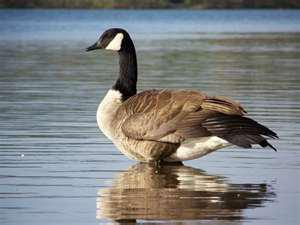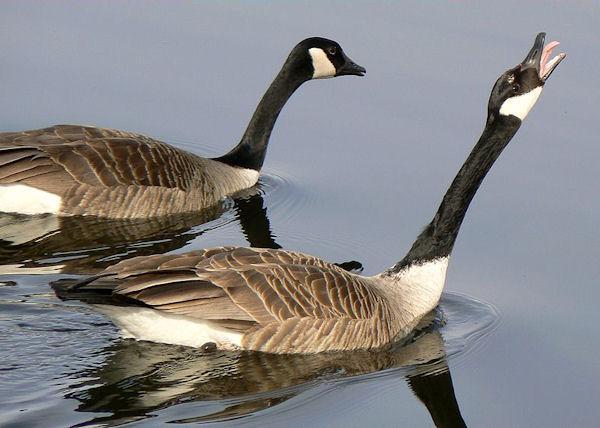The first image is the image on the left, the second image is the image on the right. For the images shown, is this caption "There are more than two birds total." true? Answer yes or no. Yes. 